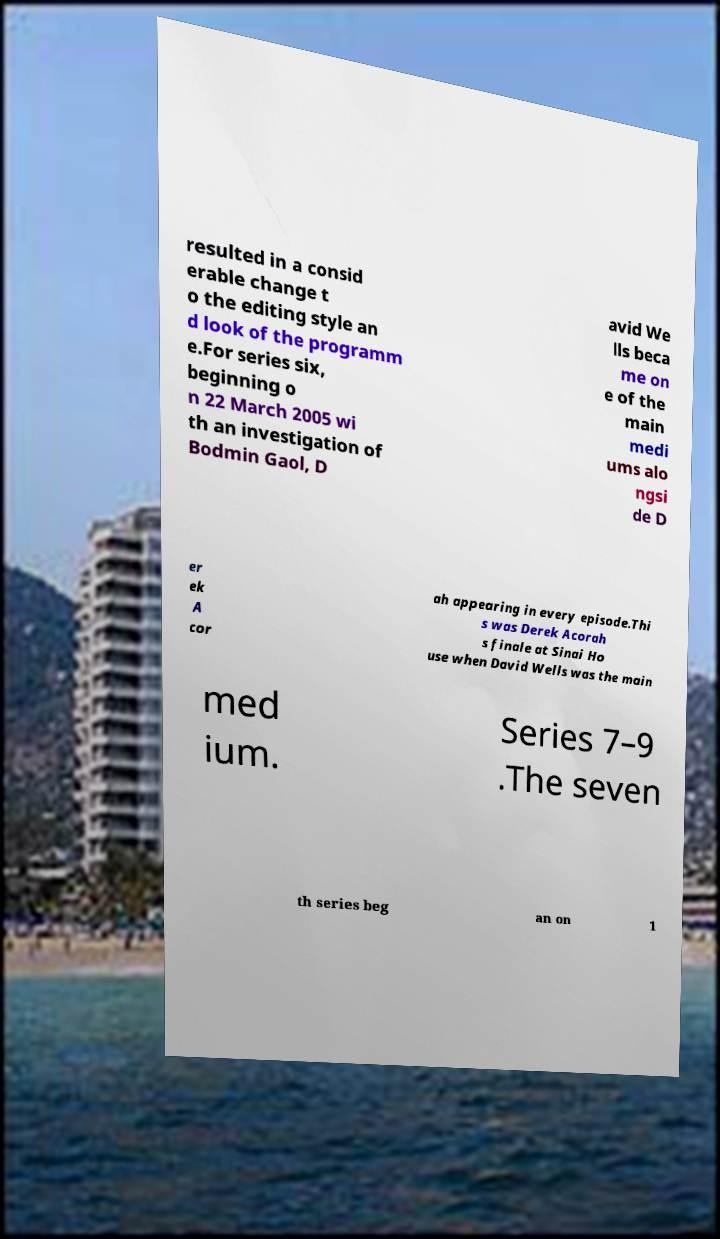Can you accurately transcribe the text from the provided image for me? resulted in a consid erable change t o the editing style an d look of the programm e.For series six, beginning o n 22 March 2005 wi th an investigation of Bodmin Gaol, D avid We lls beca me on e of the main medi ums alo ngsi de D er ek A cor ah appearing in every episode.Thi s was Derek Acorah s finale at Sinai Ho use when David Wells was the main med ium. Series 7–9 .The seven th series beg an on 1 